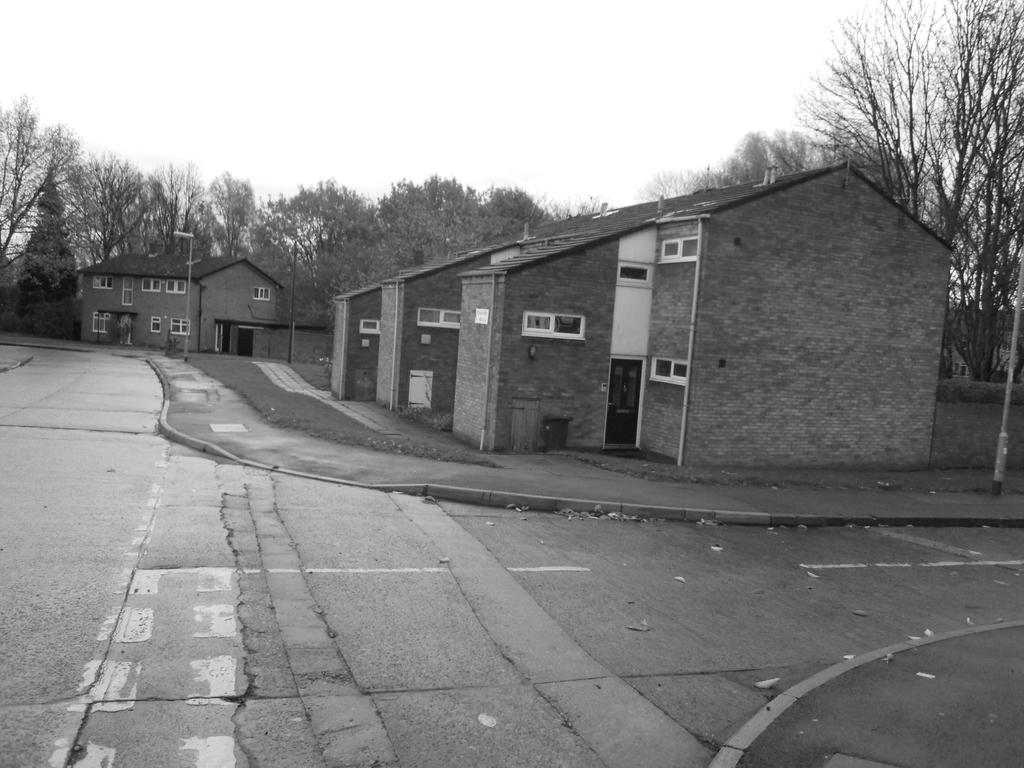What type of structures are visible in the image? There are buildings in the image. What can be seen behind the buildings? There are trees behind the buildings. What is located in front of the buildings? There are electric poles in front of the buildings. Can you hear the clock ticking in the image? There is no clock present in the image, so it is not possible to hear it ticking. 